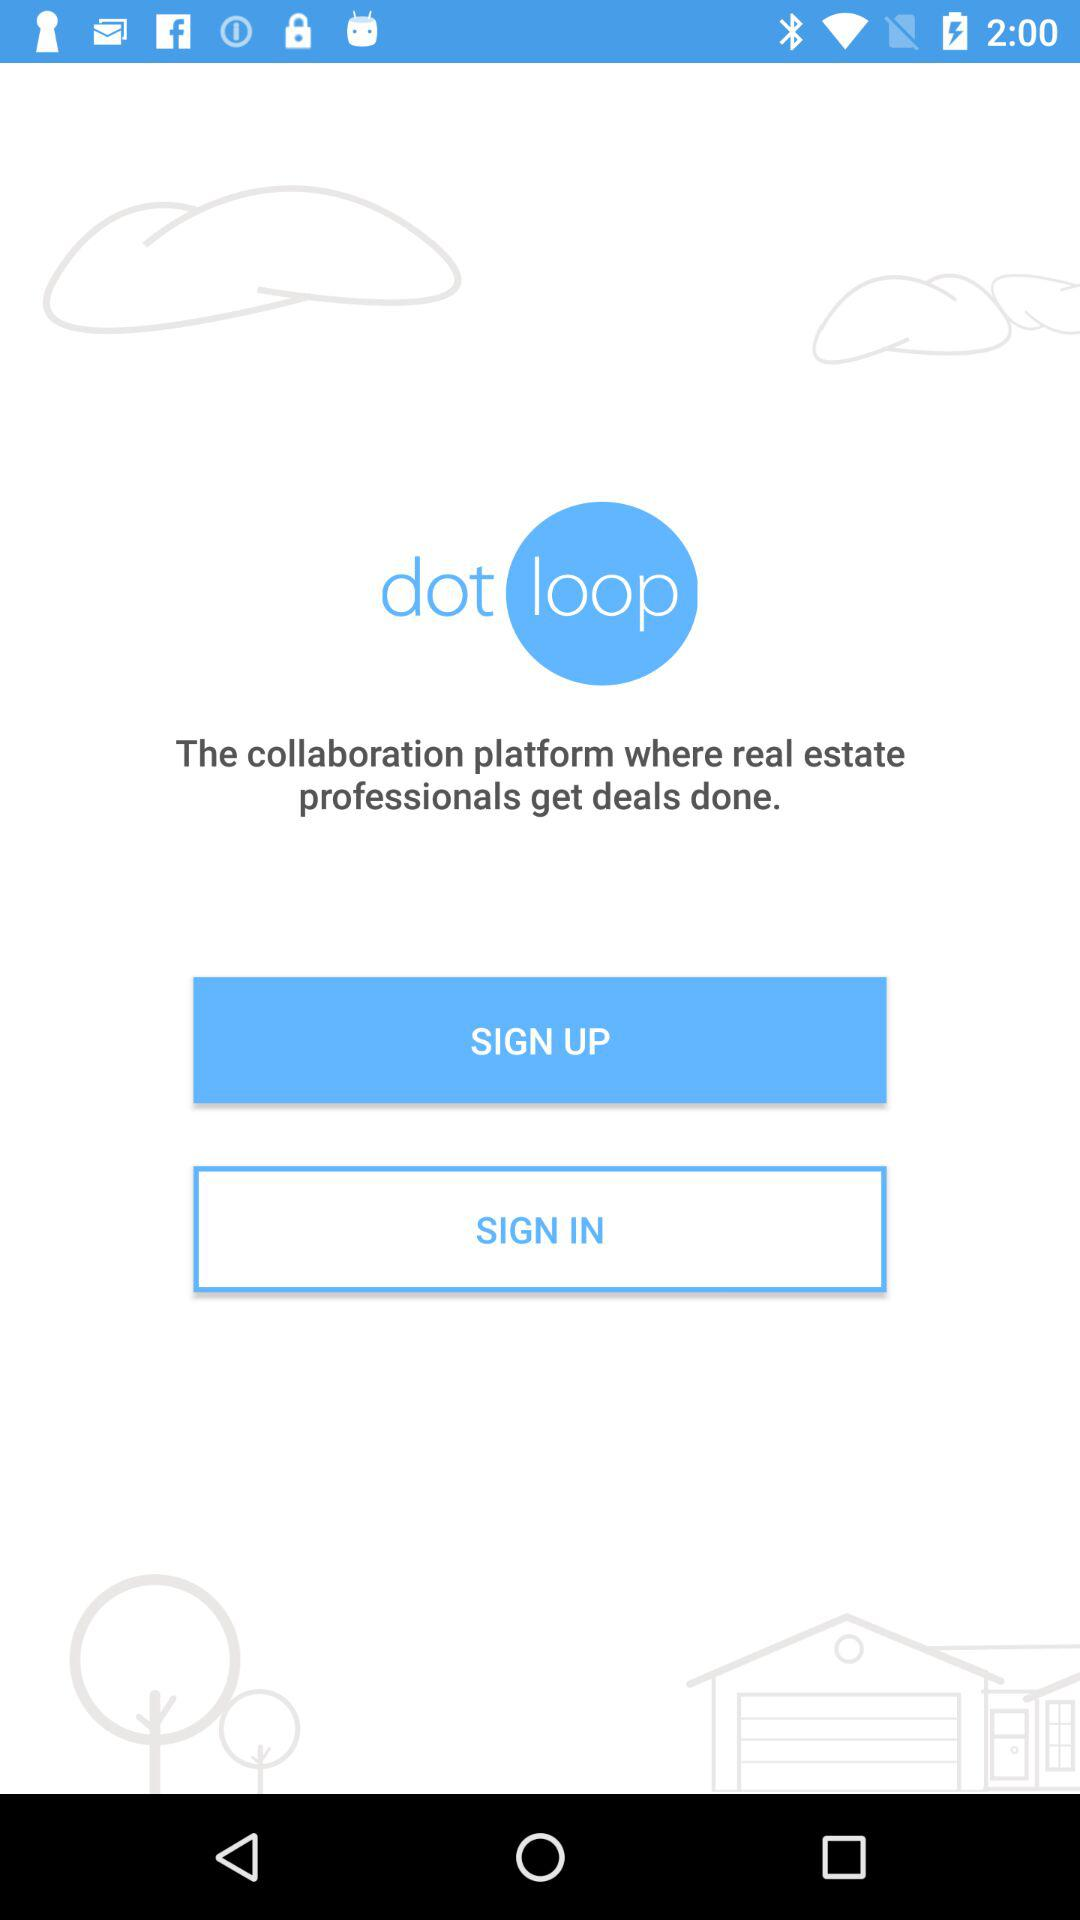What is the name of the application? The name of the application is "dotloop". 